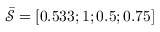Convert formula to latex. <formula><loc_0><loc_0><loc_500><loc_500>\bar { \mathcal { S } } = [ 0 . 5 3 3 ; 1 ; 0 . 5 ; 0 . 7 5 ]</formula> 